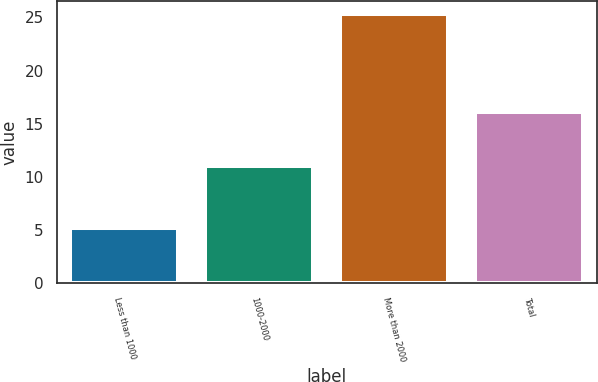Convert chart to OTSL. <chart><loc_0><loc_0><loc_500><loc_500><bar_chart><fcel>Less than 1000<fcel>1000-2000<fcel>More than 2000<fcel>Total<nl><fcel>5.2<fcel>10.97<fcel>25.29<fcel>16.07<nl></chart> 